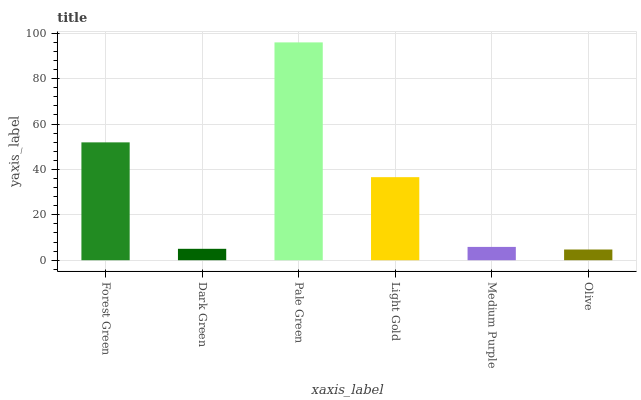Is Olive the minimum?
Answer yes or no. Yes. Is Pale Green the maximum?
Answer yes or no. Yes. Is Dark Green the minimum?
Answer yes or no. No. Is Dark Green the maximum?
Answer yes or no. No. Is Forest Green greater than Dark Green?
Answer yes or no. Yes. Is Dark Green less than Forest Green?
Answer yes or no. Yes. Is Dark Green greater than Forest Green?
Answer yes or no. No. Is Forest Green less than Dark Green?
Answer yes or no. No. Is Light Gold the high median?
Answer yes or no. Yes. Is Medium Purple the low median?
Answer yes or no. Yes. Is Olive the high median?
Answer yes or no. No. Is Forest Green the low median?
Answer yes or no. No. 